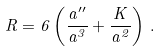Convert formula to latex. <formula><loc_0><loc_0><loc_500><loc_500>R = 6 \left ( \frac { a ^ { \prime \prime } } { a ^ { 3 } } + \frac { K } { a ^ { 2 } } \right ) \, .</formula> 